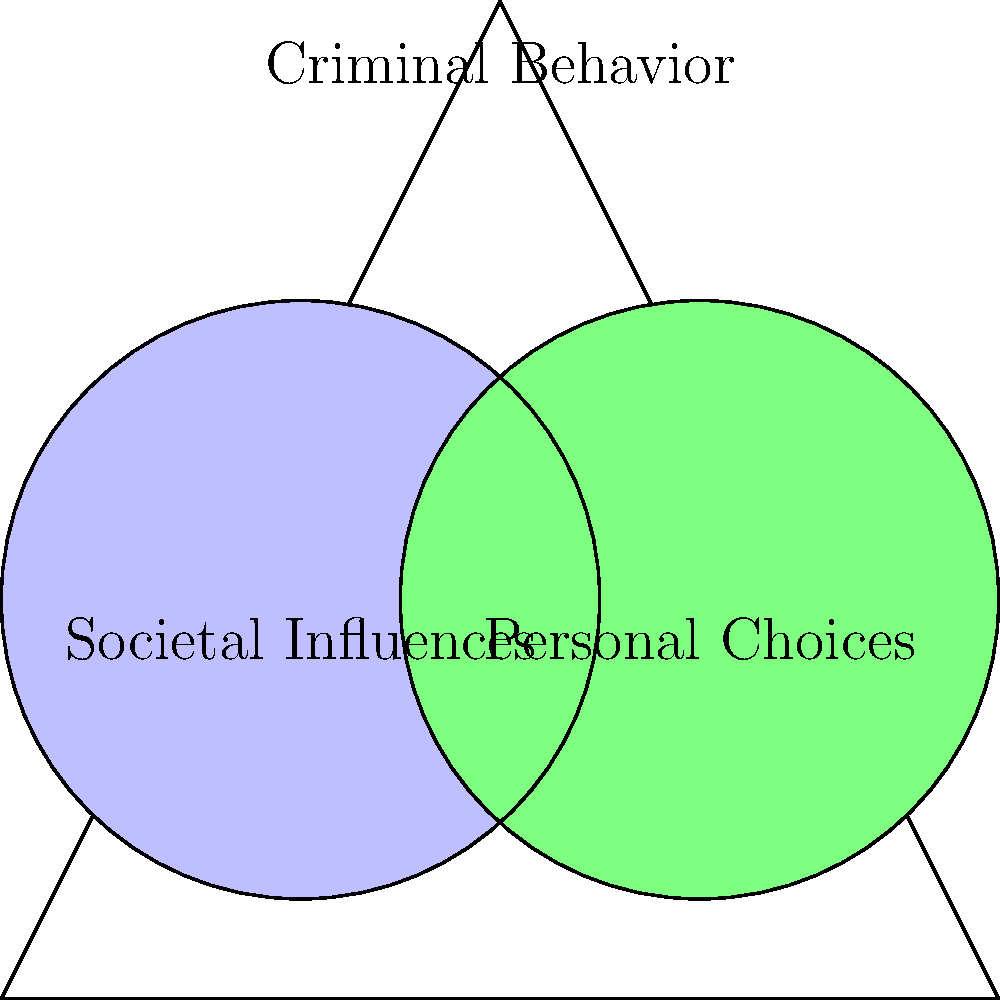In the context of criminal behavior, consider the Venn diagram where one circle represents societal influences and the other represents personal choices. What does the intersection of these two circles most likely represent? To answer this question, let's analyze the components of the Venn diagram and their relationships:

1. The outer triangle represents the overall context of criminal behavior.

2. The blue circle represents societal influences, which may include:
   - Poverty
   - Lack of education
   - Peer pressure
   - Cultural norms

3. The green circle represents personal choices, which may include:
   - Decision-making processes
   - Individual values
   - Moral compass
   - Impulse control

4. The intersection of these two circles represents the area where societal influences and personal choices overlap and interact. This intersection is crucial in understanding criminal behavior because it represents:
   - How societal factors influence personal decision-making
   - How individual choices are shaped by environmental factors
   - The complex interplay between external pressures and internal motivations

5. In the context of criminal behavior, this intersection likely represents the factors that contribute to criminal actions, such as:
   - Learned behaviors from one's environment
   - Rationalization of criminal acts based on societal circumstances
   - The impact of social conditions on personal moral standards

Therefore, the intersection most likely represents the specific factors that lead to criminal behavior, where societal influences have shaped personal choices, or where personal choices have been made in response to societal pressures.
Answer: Factors contributing to criminal behavior 